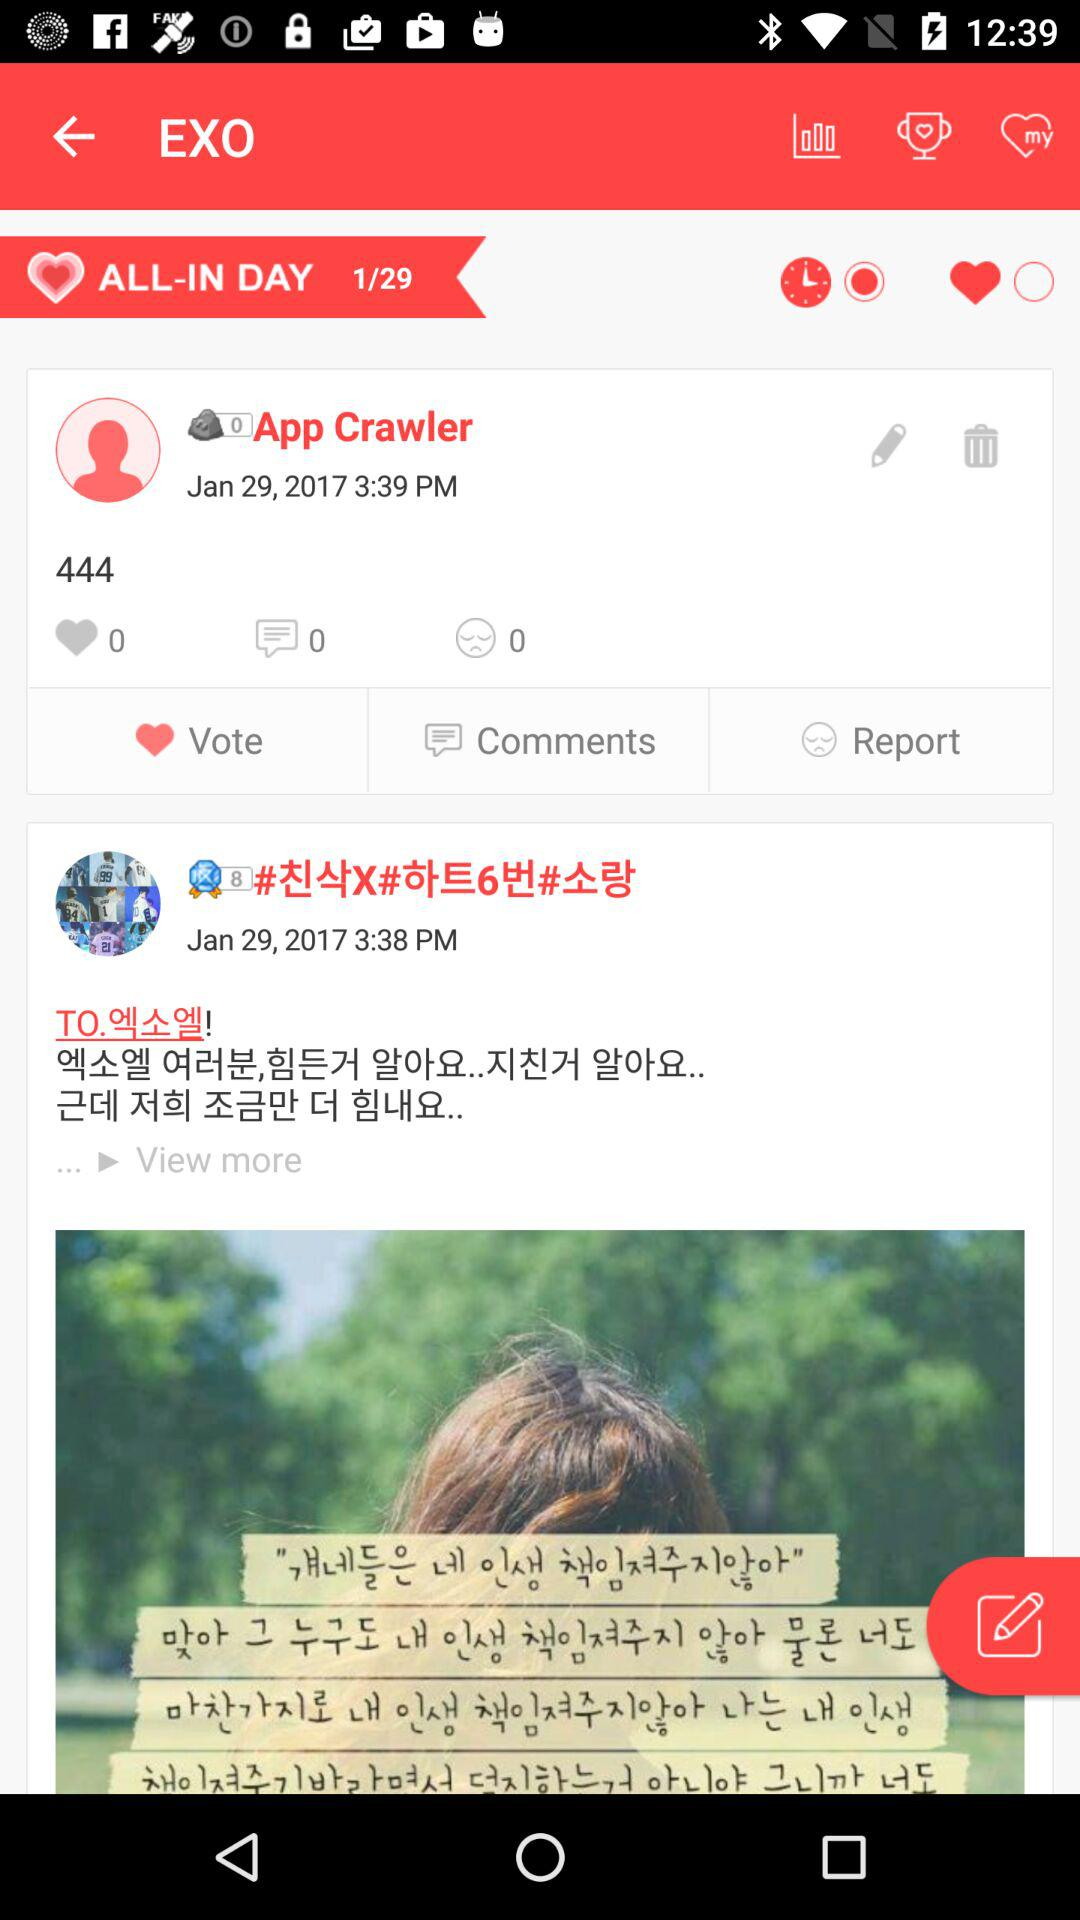How many likes are on the post by App Crawler? There are 0 likes on the post. 